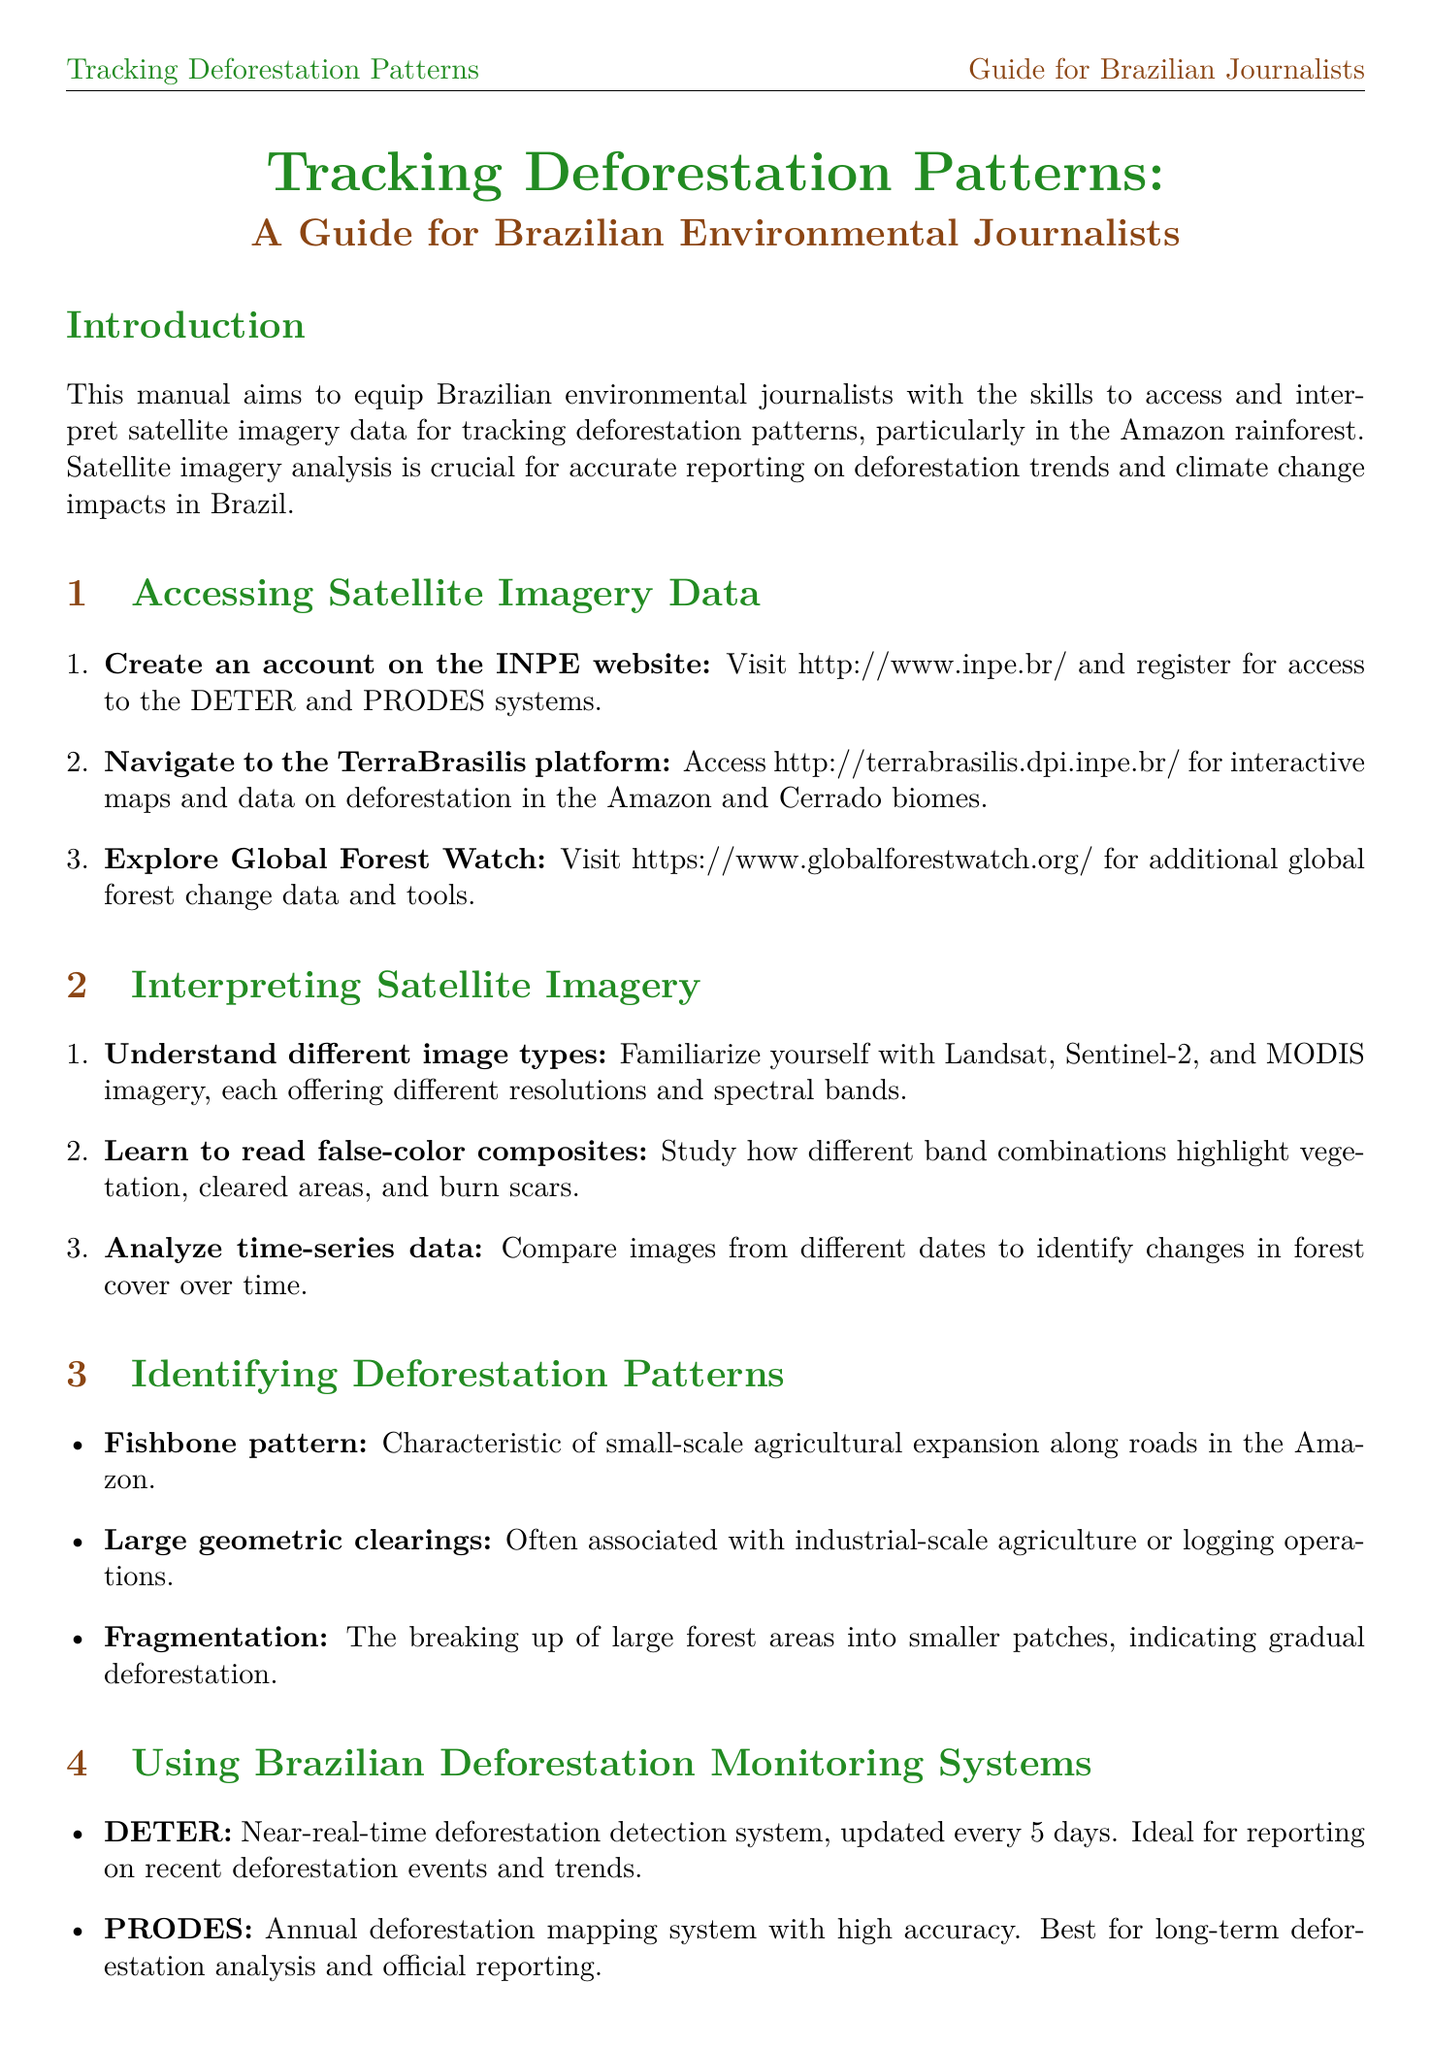What is the purpose of the manual? The manual aims to equip Brazilian environmental journalists with the skills to access and interpret satellite imagery data for tracking deforestation patterns.
Answer: Equip journalists What are the systems used for monitoring deforestation? The document lists DETER and PRODES as the systems used for monitoring deforestation in Brazil.
Answer: DETER and PRODES How often is the DETER system updated? The DETER system updates every 5 days, providing near-real-time deforestation detection.
Answer: Every 5 days What is an example of a deforestation pattern mentioned? One of the deforestation patterns identified is the "Fishbone pattern", characteristic of small-scale agricultural expansion along roads.
Answer: Fishbone pattern Which platform should be navigated to access interactive maps? The TerraBrasilis platform is recommended for accessing interactive maps and data on deforestation.
Answer: TerraBrasilis What should be done for data verification? Cross-reference with ground reports is necessary to verify data accuracy.
Answer: Cross-reference with ground reports What type of image combinations should be learned for analysis? Learning to read false-color composites is important for interpreting satellite imagery.
Answer: False-color composites What is the ideal use case for the PRODES system? The PRODES system is best for long-term deforestation analysis and official reporting.
Answer: Long-term deforestation analysis Which organizations should be contacted for ground verification? Local environmental agencies, NGOs, and indigenous communities should be contacted for verification.
Answer: Local environmental agencies, NGOs, and indigenous communities 